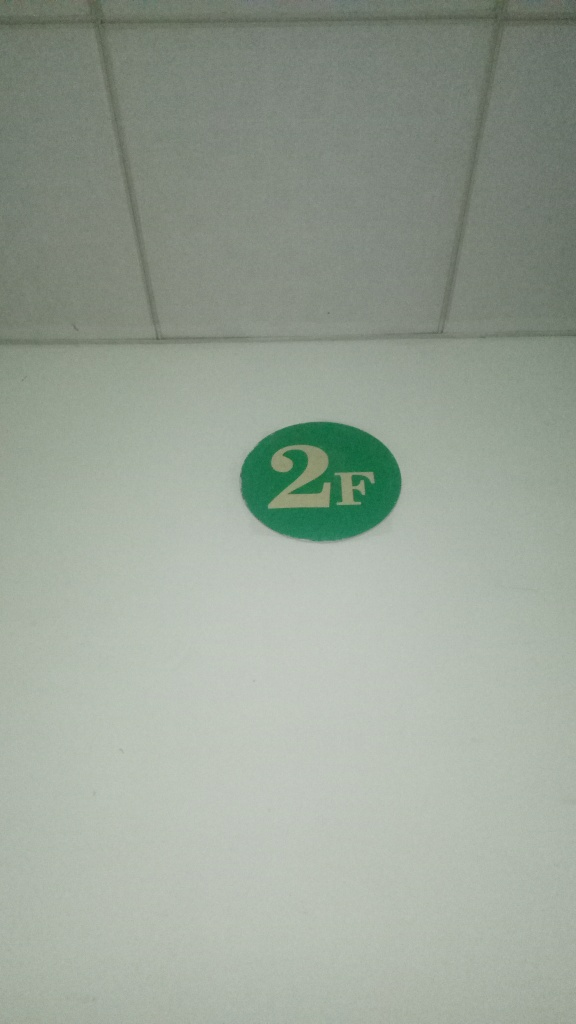Can you tell me what the green circle with '2F' might indicate? The green circle with '2F' likely indicates the location on the second floor of a building. The '2' stands for the second floor, and 'F' typically represents 'floor'. Such markers are common in public buildings, parking garages, and office complexes for ease of navigation. 